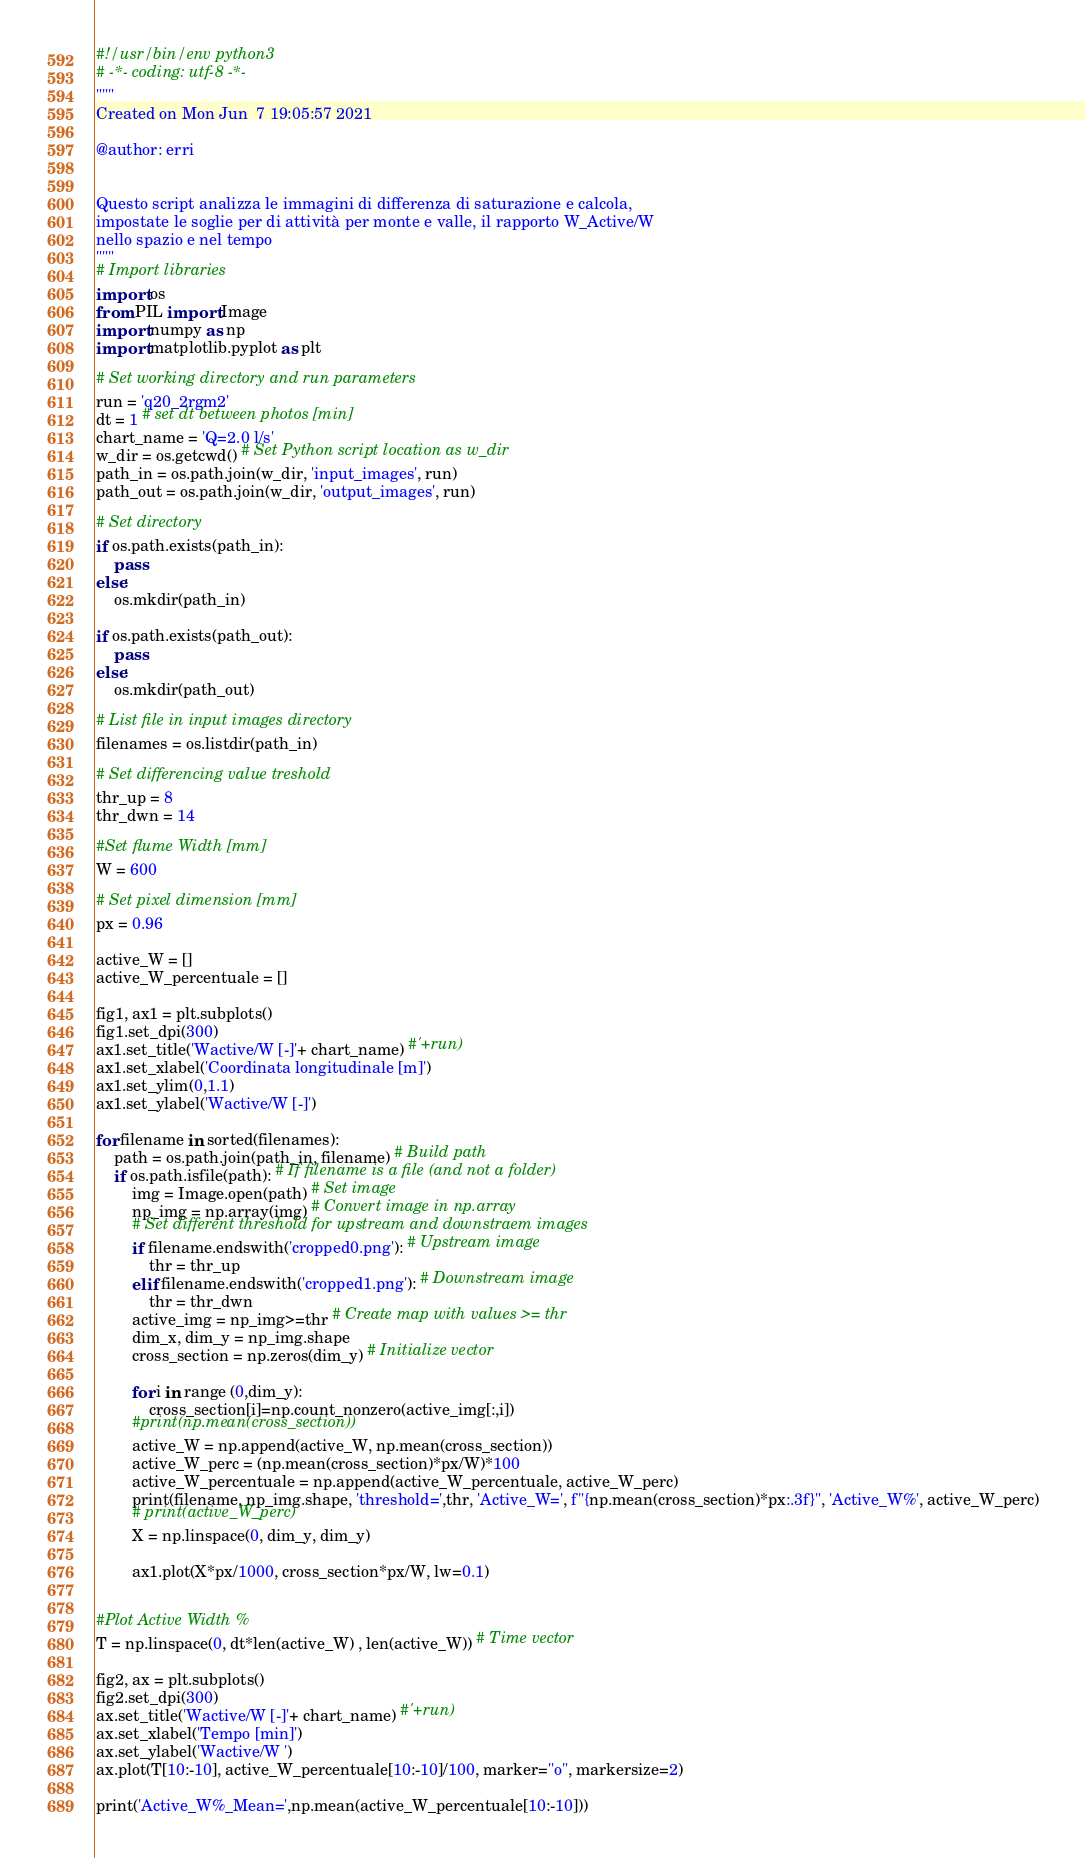Convert code to text. <code><loc_0><loc_0><loc_500><loc_500><_Python_>#!/usr/bin/env python3
# -*- coding: utf-8 -*-
"""
Created on Mon Jun  7 19:05:57 2021

@author: erri


Questo script analizza le immagini di differenza di saturazione e calcola,
impostate le soglie per di attività per monte e valle, il rapporto W_Active/W
nello spazio e nel tempo 
"""
# Import libraries
import os
from PIL import Image
import numpy as np
import matplotlib.pyplot as plt

# Set working directory and run parameters
run = 'q20_2rgm2'
dt = 1 # set dt between photos [min]
chart_name = 'Q=2.0 l/s'
w_dir = os.getcwd() # Set Python script location as w_dir
path_in = os.path.join(w_dir, 'input_images', run)
path_out = os.path.join(w_dir, 'output_images', run)

# Set directory
if os.path.exists(path_in):
    pass
else:
    os.mkdir(path_in)
    
if os.path.exists(path_out):
    pass
else:
    os.mkdir(path_out)

# List file in input images directory
filenames = os.listdir(path_in)

# Set differencing value treshold 
thr_up = 8
thr_dwn = 14

#Set flume Width [mm]
W = 600

# Set pixel dimension [mm]
px = 0.96

active_W = []
active_W_percentuale = []

fig1, ax1 = plt.subplots()
fig1.set_dpi(300)
ax1.set_title('Wactive/W [-]'+ chart_name) #'+run)
ax1.set_xlabel('Coordinata longitudinale [m]')
ax1.set_ylim(0,1.1)
ax1.set_ylabel('Wactive/W [-]')

for filename in sorted(filenames):
    path = os.path.join(path_in, filename) # Build path
    if os.path.isfile(path): # If filename is a file (and not a folder)
        img = Image.open(path) # Set image
        np_img = np.array(img) # Convert image in np.array
        # Set different threshold for upstream and downstraem images
        if filename.endswith('cropped0.png'): # Upstream image
            thr = thr_up
        elif filename.endswith('cropped1.png'): # Downstream image
            thr = thr_dwn
        active_img = np_img>=thr # Create map with values >= thr
        dim_x, dim_y = np_img.shape
        cross_section = np.zeros(dim_y) # Initialize vector
        
        for i in range (0,dim_y):
            cross_section[i]=np.count_nonzero(active_img[:,i])
        #print(np.mean(cross_section))
        active_W = np.append(active_W, np.mean(cross_section))  
        active_W_perc = (np.mean(cross_section)*px/W)*100
        active_W_percentuale = np.append(active_W_percentuale, active_W_perc)
        print(filename, np_img.shape, 'threshold=',thr, 'Active_W=', f"{np.mean(cross_section)*px:.3f}", 'Active_W%', active_W_perc)
        # print(active_W_perc)
        X = np.linspace(0, dim_y, dim_y)
        
        ax1.plot(X*px/1000, cross_section*px/W, lw=0.1)


#Plot Active Width %   
T = np.linspace(0, dt*len(active_W) , len(active_W)) # Time vector
    
fig2, ax = plt.subplots()
fig2.set_dpi(300)
ax.set_title('Wactive/W [-]'+ chart_name) #'+run)
ax.set_xlabel('Tempo [min]')
ax.set_ylabel('Wactive/W ')
ax.plot(T[10:-10], active_W_percentuale[10:-10]/100, marker="o", markersize=2)

print('Active_W%_Mean=',np.mean(active_W_percentuale[10:-10]))</code> 